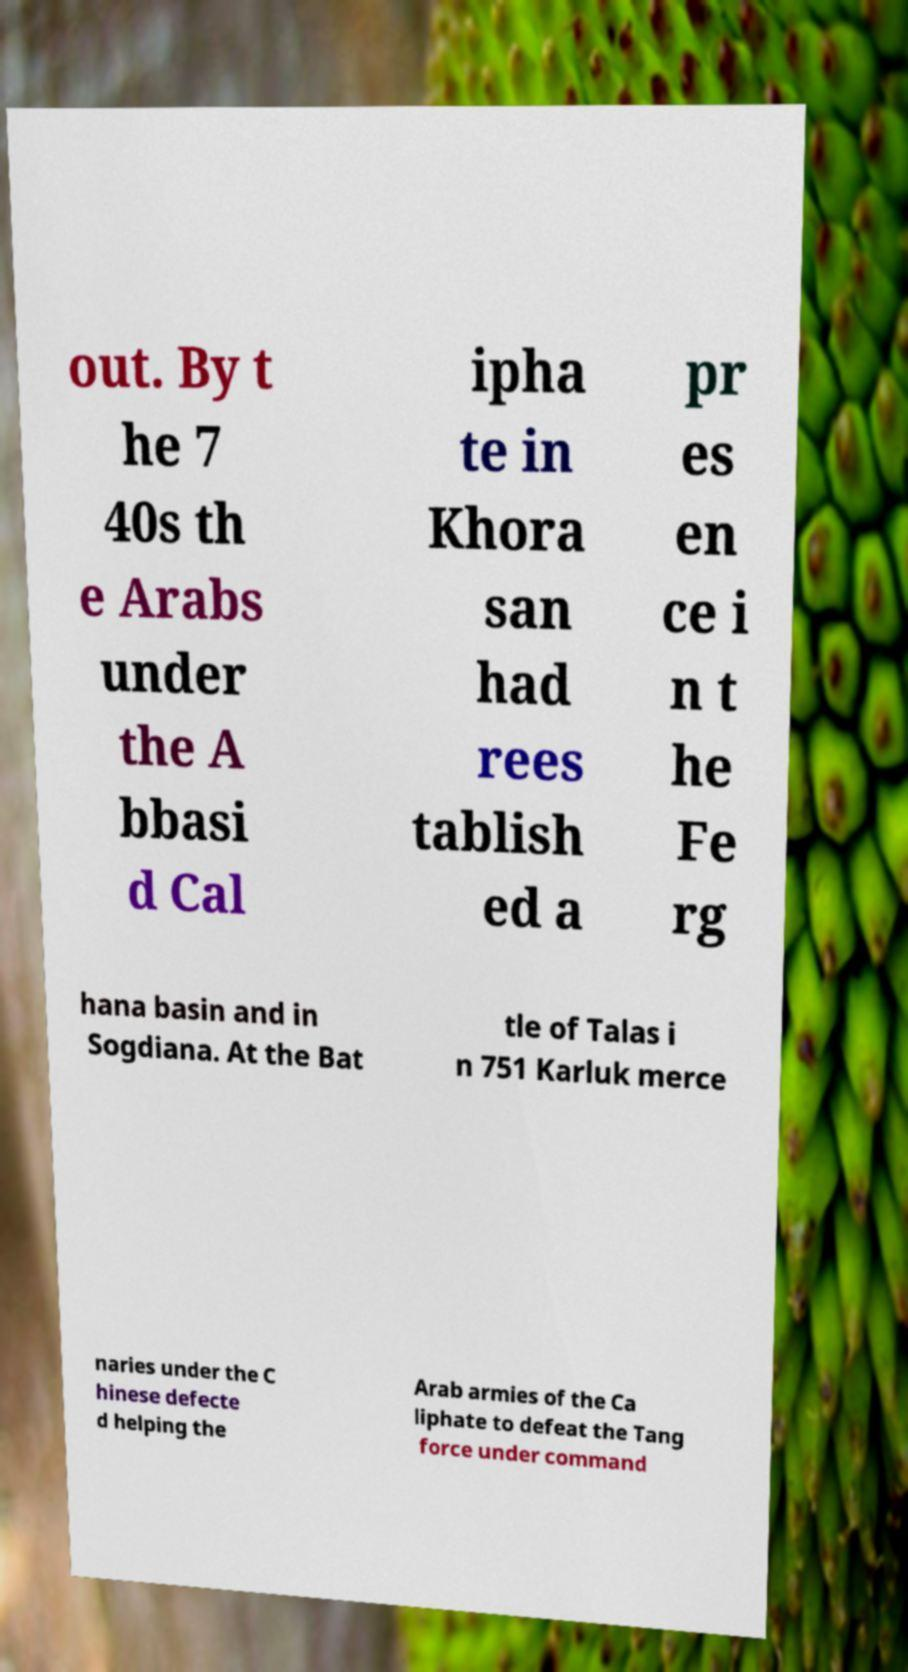Can you read and provide the text displayed in the image?This photo seems to have some interesting text. Can you extract and type it out for me? out. By t he 7 40s th e Arabs under the A bbasi d Cal ipha te in Khora san had rees tablish ed a pr es en ce i n t he Fe rg hana basin and in Sogdiana. At the Bat tle of Talas i n 751 Karluk merce naries under the C hinese defecte d helping the Arab armies of the Ca liphate to defeat the Tang force under command 